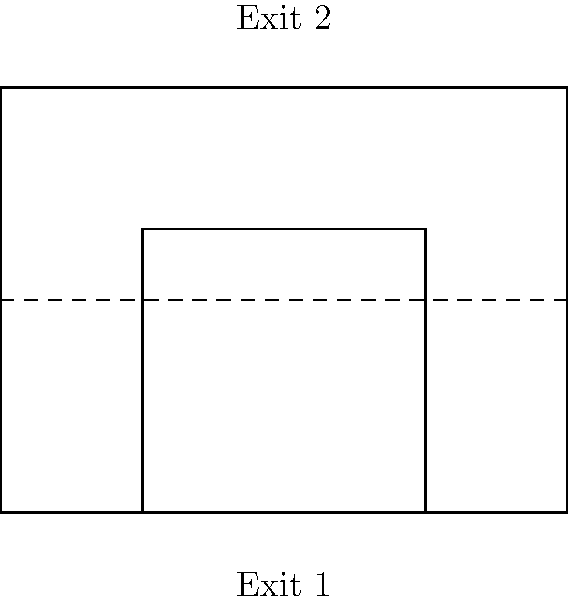In your self-driving taxi design, two emergency exits are being considered. Exit 1 has dimensions of 2 units by 2 units, while Exit 2 has dimensions of 4 units by 3 units. Are these two emergency exits congruent? If not, calculate the difference in their areas. To determine if the two emergency exits are congruent and calculate the difference in their areas if they are not, we'll follow these steps:

1. Check for congruence:
   - Exit 1: 2 units × 2 units
   - Exit 2: 4 units × 3 units
   The dimensions are different, so the exits are not congruent.

2. Calculate the area of Exit 1:
   $A_1 = 2 \times 2 = 4$ square units

3. Calculate the area of Exit 2:
   $A_2 = 4 \times 3 = 12$ square units

4. Calculate the difference in areas:
   $\text{Difference} = A_2 - A_1 = 12 - 4 = 8$ square units

Therefore, the emergency exits are not congruent, and the difference in their areas is 8 square units.
Answer: Not congruent; 8 square units difference 